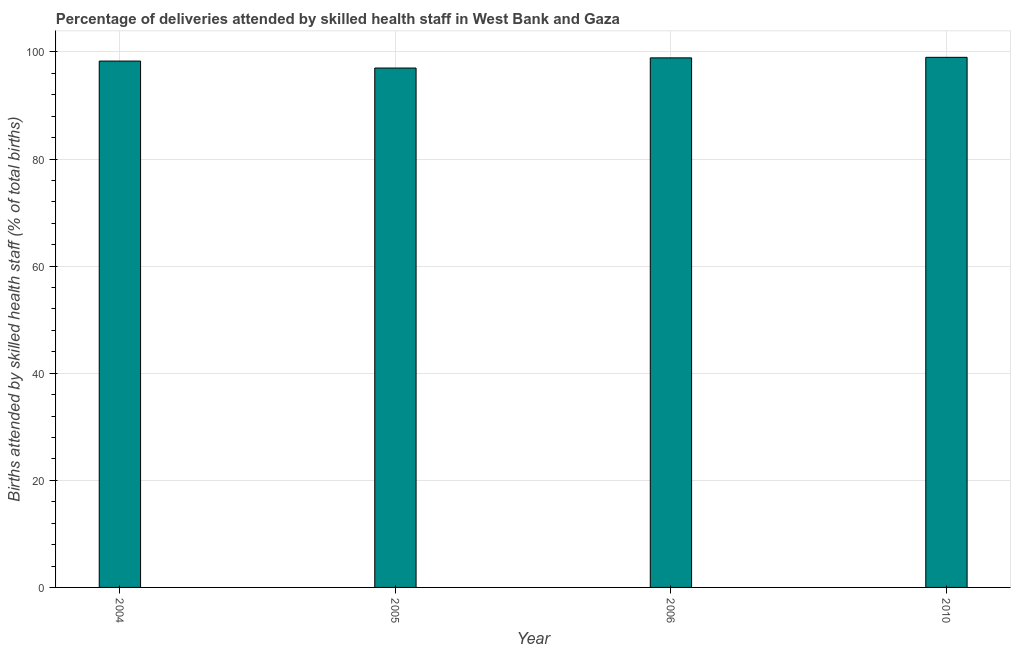Does the graph contain any zero values?
Your response must be concise. No. Does the graph contain grids?
Keep it short and to the point. Yes. What is the title of the graph?
Ensure brevity in your answer.  Percentage of deliveries attended by skilled health staff in West Bank and Gaza. What is the label or title of the X-axis?
Keep it short and to the point. Year. What is the label or title of the Y-axis?
Your answer should be compact. Births attended by skilled health staff (% of total births). What is the number of births attended by skilled health staff in 2005?
Your response must be concise. 97. Across all years, what is the maximum number of births attended by skilled health staff?
Give a very brief answer. 99. Across all years, what is the minimum number of births attended by skilled health staff?
Your answer should be compact. 97. In which year was the number of births attended by skilled health staff minimum?
Ensure brevity in your answer.  2005. What is the sum of the number of births attended by skilled health staff?
Provide a succinct answer. 393.2. What is the difference between the number of births attended by skilled health staff in 2004 and 2006?
Provide a short and direct response. -0.6. What is the average number of births attended by skilled health staff per year?
Keep it short and to the point. 98.3. What is the median number of births attended by skilled health staff?
Your response must be concise. 98.6. What is the ratio of the number of births attended by skilled health staff in 2005 to that in 2010?
Offer a very short reply. 0.98. Is the number of births attended by skilled health staff in 2005 less than that in 2010?
Offer a very short reply. Yes. What is the difference between the highest and the second highest number of births attended by skilled health staff?
Offer a terse response. 0.1. Is the sum of the number of births attended by skilled health staff in 2004 and 2010 greater than the maximum number of births attended by skilled health staff across all years?
Your answer should be very brief. Yes. Are all the bars in the graph horizontal?
Offer a very short reply. No. What is the difference between two consecutive major ticks on the Y-axis?
Make the answer very short. 20. What is the Births attended by skilled health staff (% of total births) in 2004?
Provide a succinct answer. 98.3. What is the Births attended by skilled health staff (% of total births) in 2005?
Your response must be concise. 97. What is the Births attended by skilled health staff (% of total births) in 2006?
Provide a short and direct response. 98.9. What is the Births attended by skilled health staff (% of total births) in 2010?
Give a very brief answer. 99. What is the difference between the Births attended by skilled health staff (% of total births) in 2004 and 2006?
Give a very brief answer. -0.6. What is the difference between the Births attended by skilled health staff (% of total births) in 2006 and 2010?
Provide a succinct answer. -0.1. What is the ratio of the Births attended by skilled health staff (% of total births) in 2004 to that in 2005?
Offer a very short reply. 1.01. What is the ratio of the Births attended by skilled health staff (% of total births) in 2004 to that in 2006?
Keep it short and to the point. 0.99. What is the ratio of the Births attended by skilled health staff (% of total births) in 2006 to that in 2010?
Offer a very short reply. 1. 